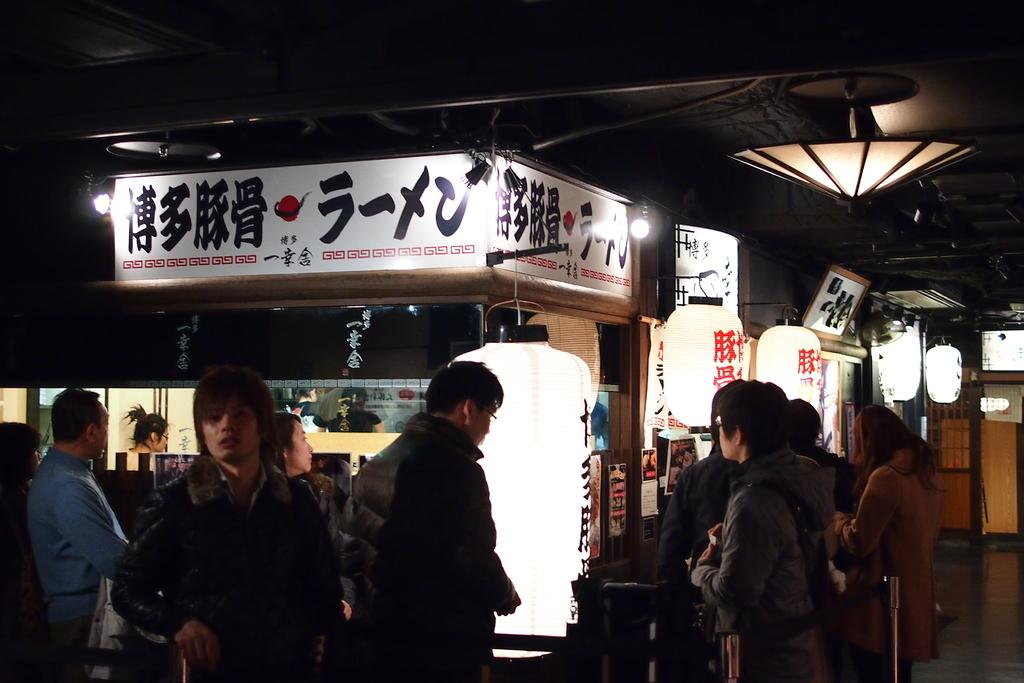Who or what can be seen in the image? There are people in the image. What objects are present in the image? There are poles in the image. What can be seen in the background of the image? There is a stall, hoardings, lights, glass, and posters in the background of the image. What word is being spelled out by the trucks in the image? There are no trucks present in the image, so it is not possible to answer that question. 